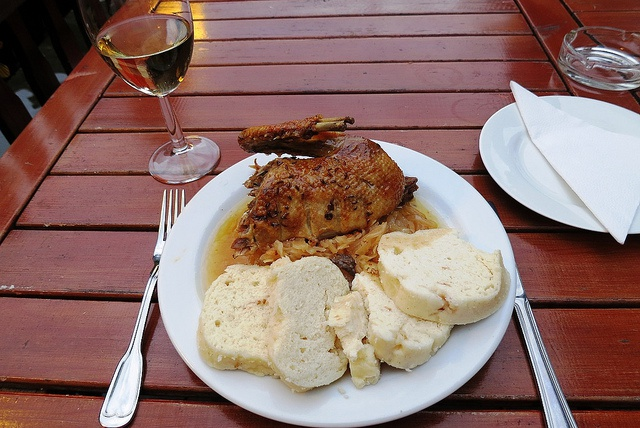Describe the objects in this image and their specific colors. I can see dining table in brown, lightgray, maroon, darkgray, and black tones, wine glass in black, maroon, darkgray, and brown tones, fork in black, white, darkgray, and gray tones, and knife in black, lightgray, gray, lavender, and darkgray tones in this image. 